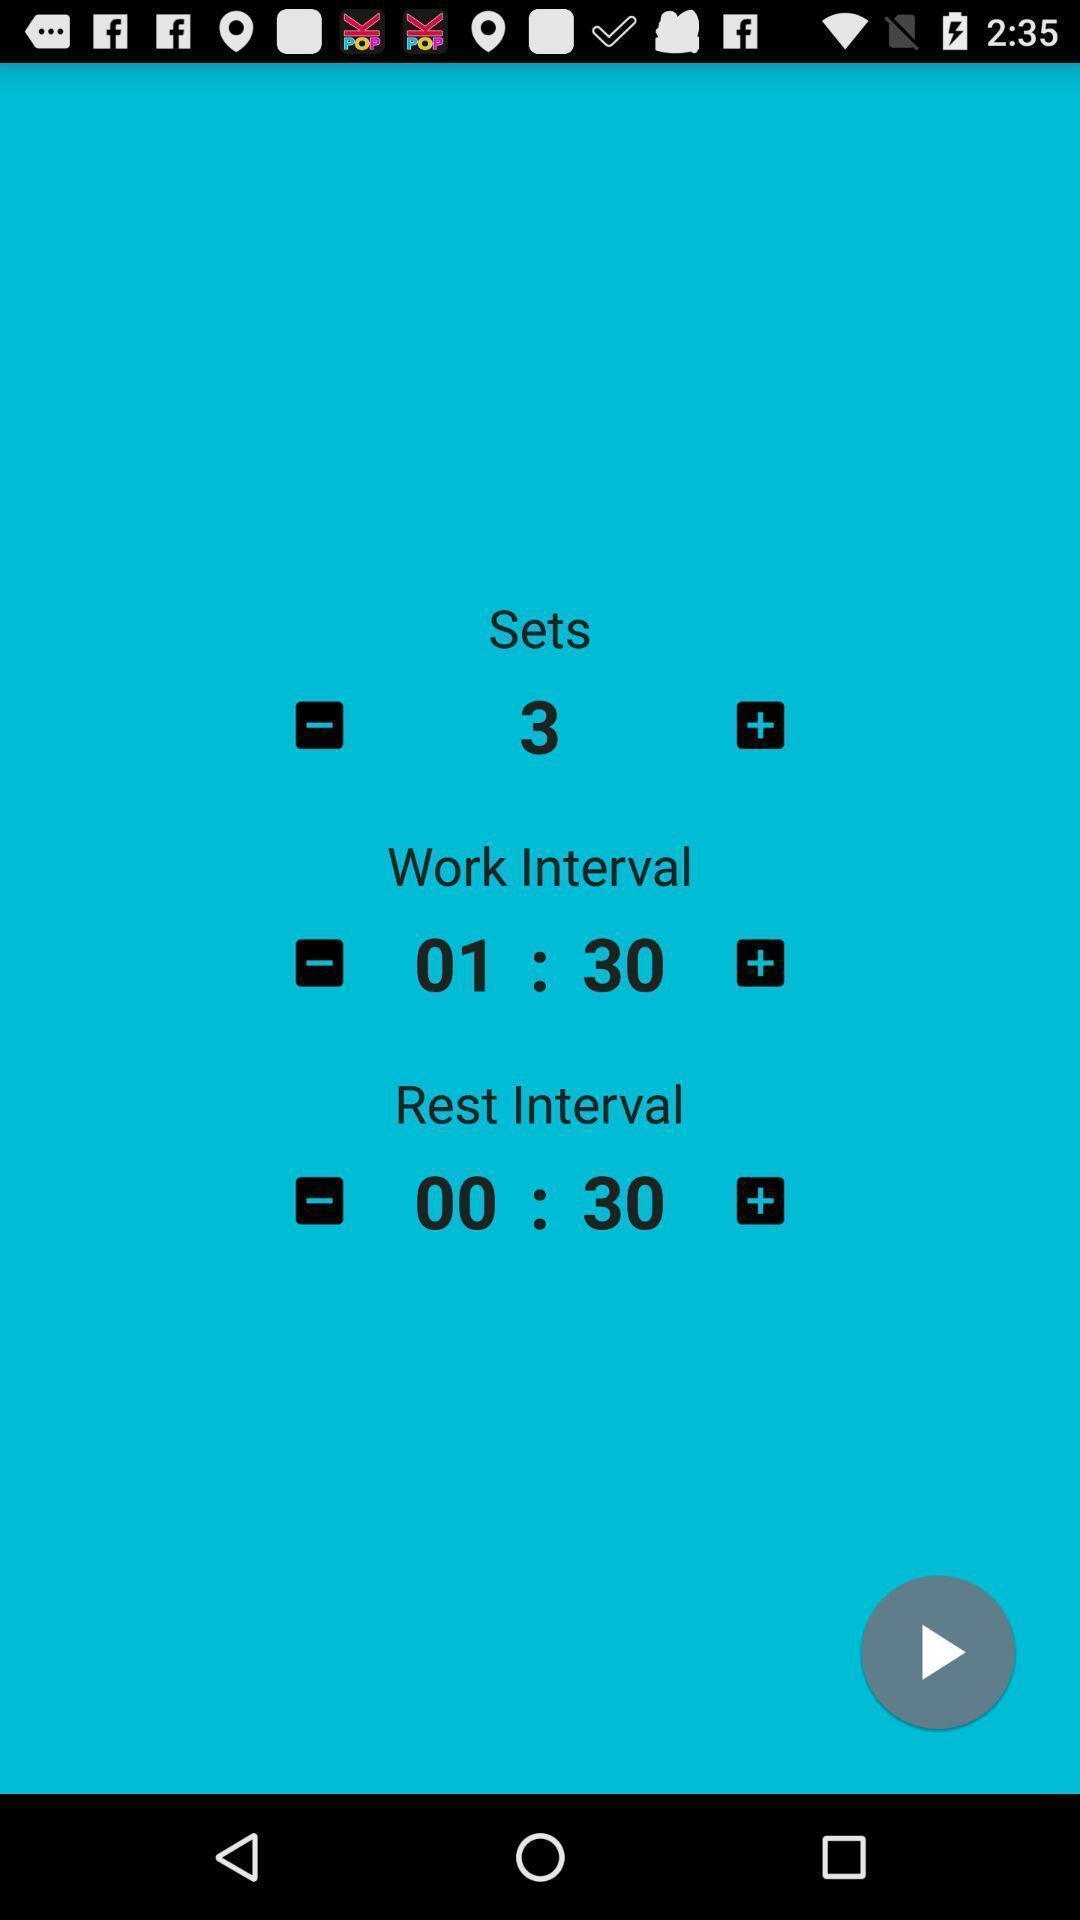What can you discern from this picture? Screen displaying the page of a fitness app. 